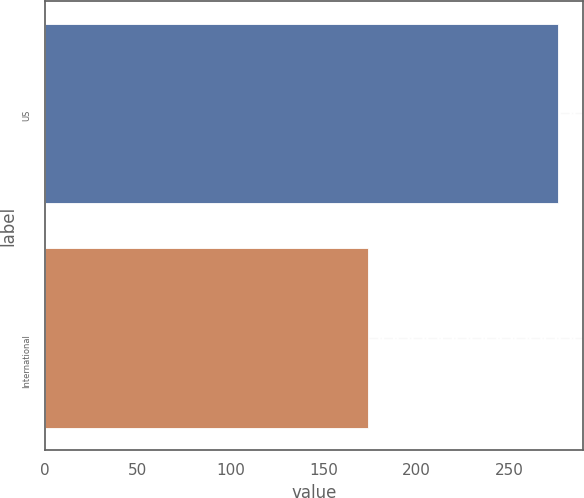Convert chart. <chart><loc_0><loc_0><loc_500><loc_500><bar_chart><fcel>US<fcel>International<nl><fcel>276<fcel>174<nl></chart> 